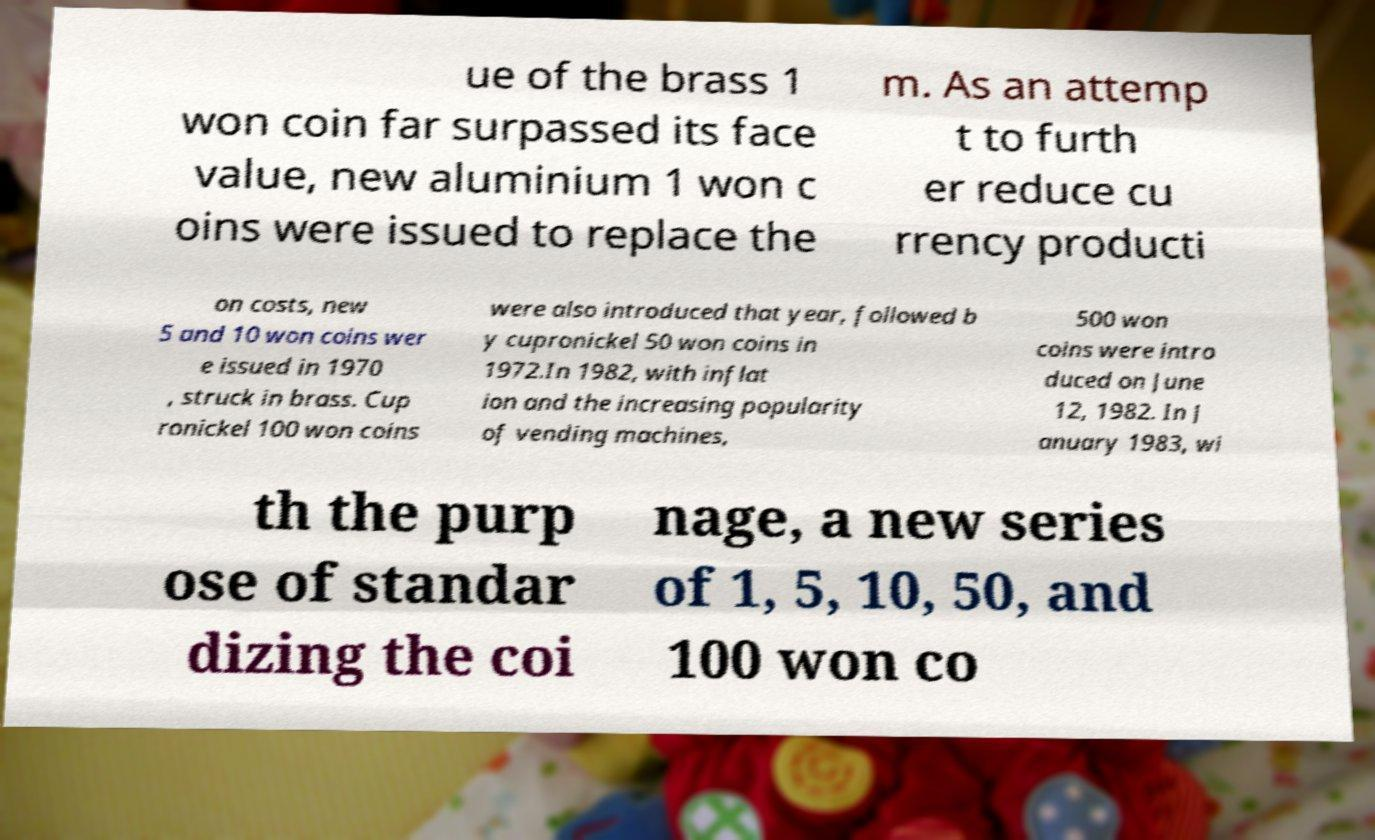For documentation purposes, I need the text within this image transcribed. Could you provide that? ue of the brass 1 won coin far surpassed its face value, new aluminium 1 won c oins were issued to replace the m. As an attemp t to furth er reduce cu rrency producti on costs, new 5 and 10 won coins wer e issued in 1970 , struck in brass. Cup ronickel 100 won coins were also introduced that year, followed b y cupronickel 50 won coins in 1972.In 1982, with inflat ion and the increasing popularity of vending machines, 500 won coins were intro duced on June 12, 1982. In J anuary 1983, wi th the purp ose of standar dizing the coi nage, a new series of 1, 5, 10, 50, and 100 won co 